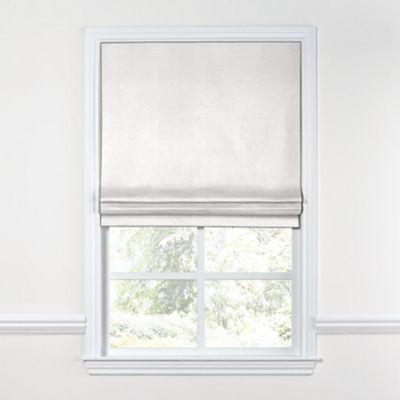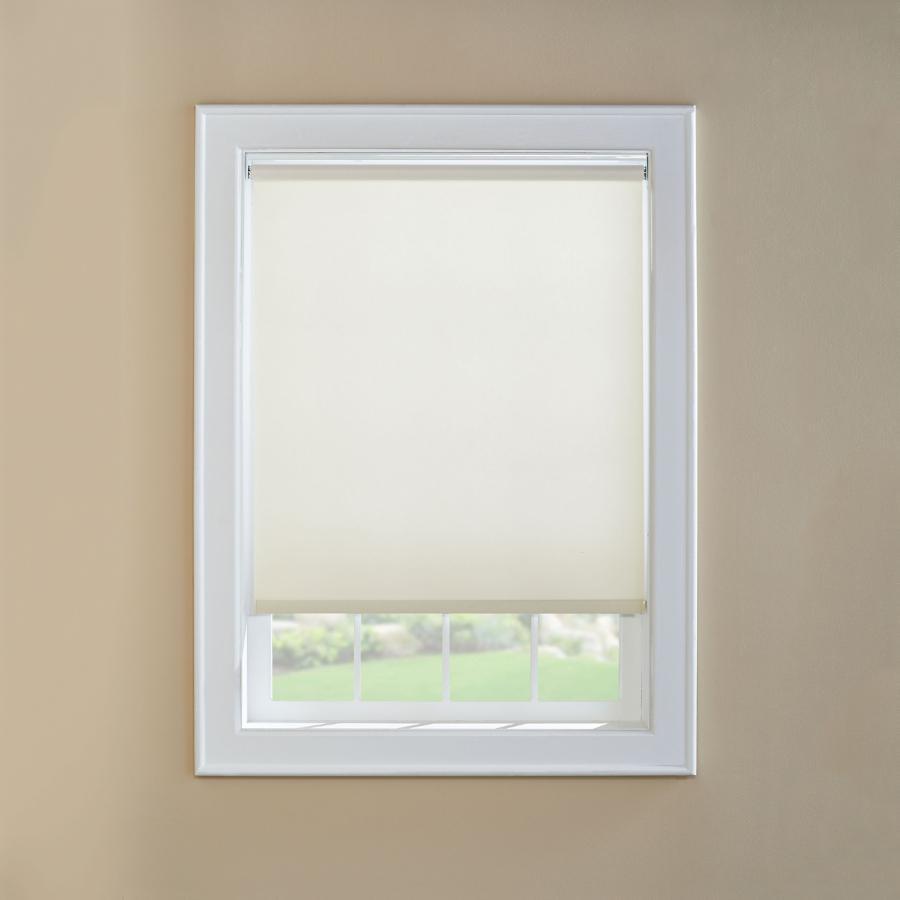The first image is the image on the left, the second image is the image on the right. Evaluate the accuracy of this statement regarding the images: "There are a total of two windows with white frames shown.". Is it true? Answer yes or no. Yes. The first image is the image on the left, the second image is the image on the right. Examine the images to the left and right. Is the description "The left and right image contains the same number of blinds." accurate? Answer yes or no. Yes. 